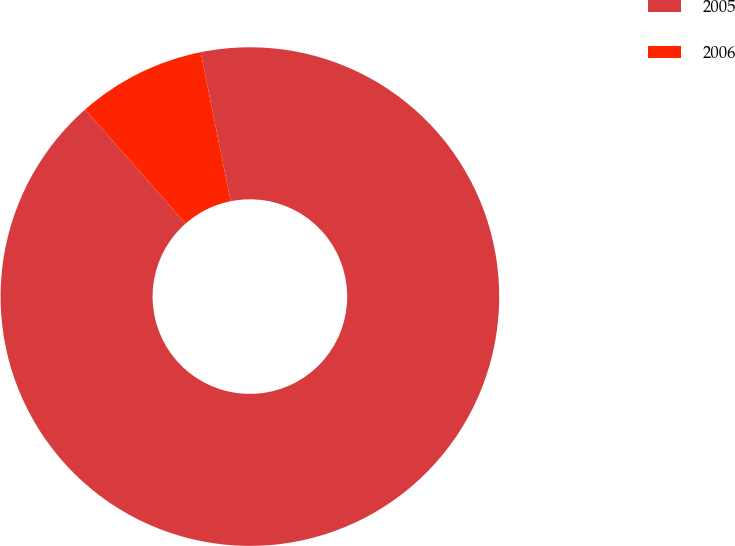<chart> <loc_0><loc_0><loc_500><loc_500><pie_chart><fcel>2005<fcel>2006<nl><fcel>91.67%<fcel>8.33%<nl></chart> 